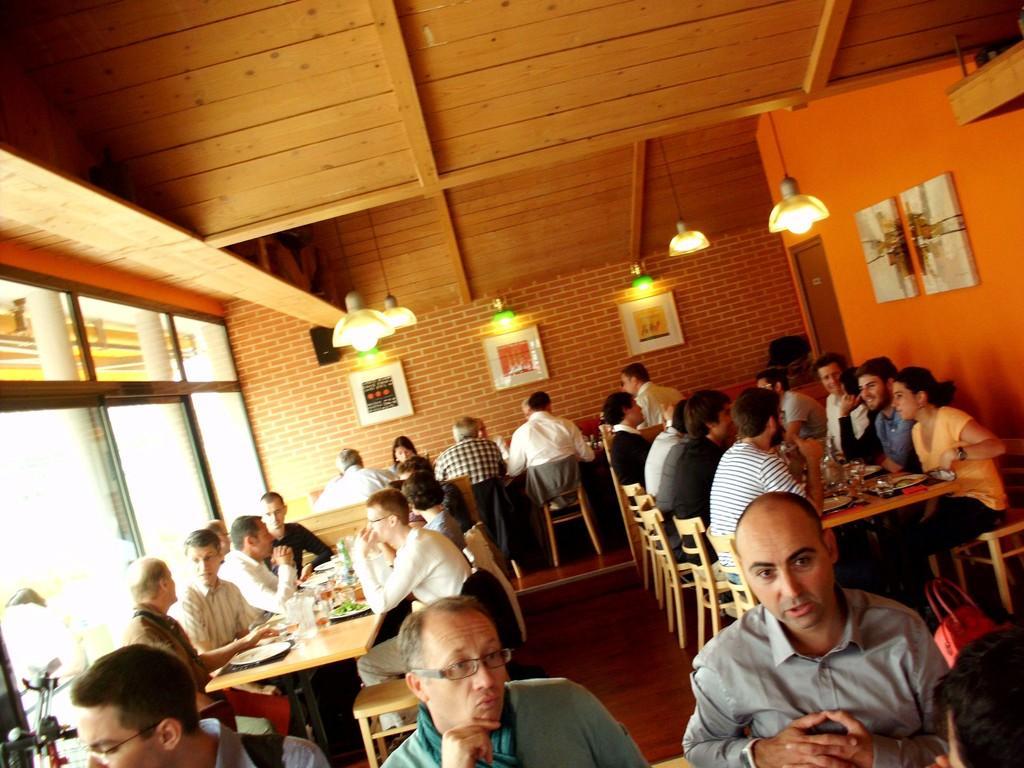How would you summarize this image in a sentence or two? In the foreground of this image, there are three men. In the background, there are people sitting on the chairs in front of tables on which, there are platters with food, glasses and few more objects. We can also see lights hanging to the ceiling, few frames, a door, floor and the glass walls on the left. 